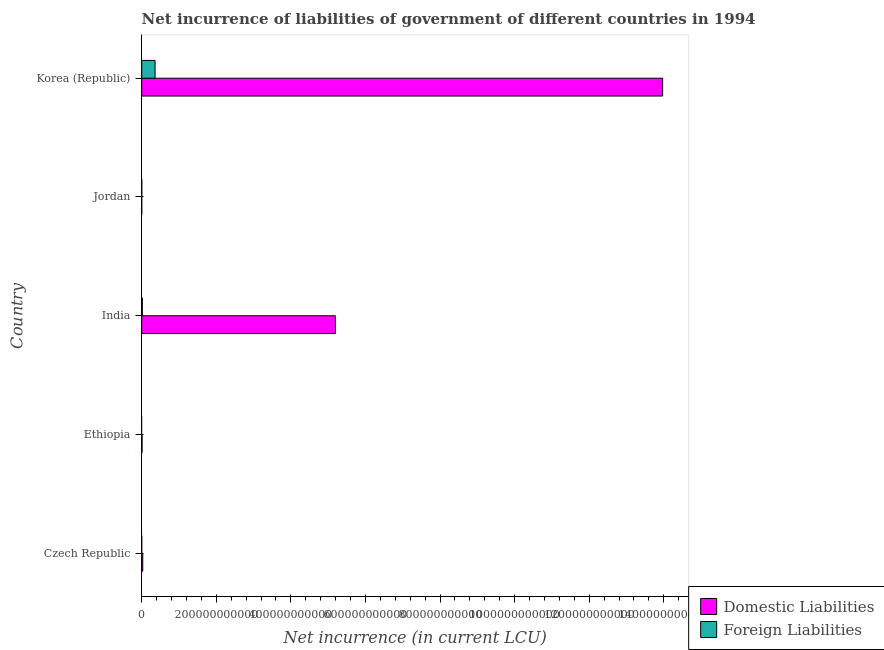Are the number of bars on each tick of the Y-axis equal?
Provide a succinct answer. No. How many bars are there on the 4th tick from the top?
Keep it short and to the point. 1. How many bars are there on the 1st tick from the bottom?
Your answer should be compact. 1. What is the label of the 5th group of bars from the top?
Ensure brevity in your answer.  Czech Republic. In how many cases, is the number of bars for a given country not equal to the number of legend labels?
Ensure brevity in your answer.  3. What is the net incurrence of domestic liabilities in Czech Republic?
Your answer should be compact. 2.80e+09. Across all countries, what is the maximum net incurrence of foreign liabilities?
Your answer should be very brief. 3.58e+1. In which country was the net incurrence of domestic liabilities maximum?
Offer a very short reply. Korea (Republic). What is the total net incurrence of foreign liabilities in the graph?
Provide a short and direct response. 3.75e+1. What is the difference between the net incurrence of foreign liabilities in India and that in Jordan?
Give a very brief answer. 1.66e+09. What is the difference between the net incurrence of domestic liabilities in Korea (Republic) and the net incurrence of foreign liabilities in Jordan?
Provide a succinct answer. 1.40e+12. What is the average net incurrence of foreign liabilities per country?
Offer a terse response. 7.50e+09. What is the difference between the net incurrence of foreign liabilities and net incurrence of domestic liabilities in India?
Ensure brevity in your answer.  -5.18e+11. What is the ratio of the net incurrence of domestic liabilities in Czech Republic to that in Ethiopia?
Offer a very short reply. 3.03. What is the difference between the highest and the second highest net incurrence of domestic liabilities?
Give a very brief answer. 8.78e+11. What is the difference between the highest and the lowest net incurrence of foreign liabilities?
Your response must be concise. 3.58e+1. What is the difference between two consecutive major ticks on the X-axis?
Offer a terse response. 2.00e+11. How many legend labels are there?
Your response must be concise. 2. What is the title of the graph?
Provide a short and direct response. Net incurrence of liabilities of government of different countries in 1994. Does "Broad money growth" appear as one of the legend labels in the graph?
Your answer should be compact. No. What is the label or title of the X-axis?
Offer a terse response. Net incurrence (in current LCU). What is the label or title of the Y-axis?
Offer a very short reply. Country. What is the Net incurrence (in current LCU) of Domestic Liabilities in Czech Republic?
Provide a succinct answer. 2.80e+09. What is the Net incurrence (in current LCU) in Foreign Liabilities in Czech Republic?
Offer a very short reply. 0. What is the Net incurrence (in current LCU) in Domestic Liabilities in Ethiopia?
Make the answer very short. 9.25e+08. What is the Net incurrence (in current LCU) of Foreign Liabilities in Ethiopia?
Your response must be concise. 0. What is the Net incurrence (in current LCU) of Domestic Liabilities in India?
Make the answer very short. 5.19e+11. What is the Net incurrence (in current LCU) in Foreign Liabilities in India?
Provide a short and direct response. 1.69e+09. What is the Net incurrence (in current LCU) of Foreign Liabilities in Jordan?
Keep it short and to the point. 3.18e+07. What is the Net incurrence (in current LCU) of Domestic Liabilities in Korea (Republic)?
Offer a very short reply. 1.40e+12. What is the Net incurrence (in current LCU) of Foreign Liabilities in Korea (Republic)?
Keep it short and to the point. 3.58e+1. Across all countries, what is the maximum Net incurrence (in current LCU) of Domestic Liabilities?
Your answer should be compact. 1.40e+12. Across all countries, what is the maximum Net incurrence (in current LCU) of Foreign Liabilities?
Keep it short and to the point. 3.58e+1. What is the total Net incurrence (in current LCU) in Domestic Liabilities in the graph?
Your answer should be very brief. 1.92e+12. What is the total Net incurrence (in current LCU) in Foreign Liabilities in the graph?
Provide a short and direct response. 3.75e+1. What is the difference between the Net incurrence (in current LCU) of Domestic Liabilities in Czech Republic and that in Ethiopia?
Offer a very short reply. 1.88e+09. What is the difference between the Net incurrence (in current LCU) in Domestic Liabilities in Czech Republic and that in India?
Offer a terse response. -5.17e+11. What is the difference between the Net incurrence (in current LCU) of Domestic Liabilities in Czech Republic and that in Korea (Republic)?
Ensure brevity in your answer.  -1.39e+12. What is the difference between the Net incurrence (in current LCU) in Domestic Liabilities in Ethiopia and that in India?
Provide a succinct answer. -5.18e+11. What is the difference between the Net incurrence (in current LCU) of Domestic Liabilities in Ethiopia and that in Korea (Republic)?
Your answer should be compact. -1.40e+12. What is the difference between the Net incurrence (in current LCU) of Foreign Liabilities in India and that in Jordan?
Keep it short and to the point. 1.66e+09. What is the difference between the Net incurrence (in current LCU) in Domestic Liabilities in India and that in Korea (Republic)?
Your response must be concise. -8.78e+11. What is the difference between the Net incurrence (in current LCU) of Foreign Liabilities in India and that in Korea (Republic)?
Keep it short and to the point. -3.41e+1. What is the difference between the Net incurrence (in current LCU) of Foreign Liabilities in Jordan and that in Korea (Republic)?
Ensure brevity in your answer.  -3.58e+1. What is the difference between the Net incurrence (in current LCU) of Domestic Liabilities in Czech Republic and the Net incurrence (in current LCU) of Foreign Liabilities in India?
Offer a terse response. 1.11e+09. What is the difference between the Net incurrence (in current LCU) of Domestic Liabilities in Czech Republic and the Net incurrence (in current LCU) of Foreign Liabilities in Jordan?
Give a very brief answer. 2.77e+09. What is the difference between the Net incurrence (in current LCU) in Domestic Liabilities in Czech Republic and the Net incurrence (in current LCU) in Foreign Liabilities in Korea (Republic)?
Your answer should be compact. -3.30e+1. What is the difference between the Net incurrence (in current LCU) of Domestic Liabilities in Ethiopia and the Net incurrence (in current LCU) of Foreign Liabilities in India?
Offer a very short reply. -7.65e+08. What is the difference between the Net incurrence (in current LCU) of Domestic Liabilities in Ethiopia and the Net incurrence (in current LCU) of Foreign Liabilities in Jordan?
Offer a very short reply. 8.93e+08. What is the difference between the Net incurrence (in current LCU) of Domestic Liabilities in Ethiopia and the Net incurrence (in current LCU) of Foreign Liabilities in Korea (Republic)?
Ensure brevity in your answer.  -3.49e+1. What is the difference between the Net incurrence (in current LCU) in Domestic Liabilities in India and the Net incurrence (in current LCU) in Foreign Liabilities in Jordan?
Provide a short and direct response. 5.19e+11. What is the difference between the Net incurrence (in current LCU) of Domestic Liabilities in India and the Net incurrence (in current LCU) of Foreign Liabilities in Korea (Republic)?
Your answer should be compact. 4.84e+11. What is the average Net incurrence (in current LCU) in Domestic Liabilities per country?
Ensure brevity in your answer.  3.84e+11. What is the average Net incurrence (in current LCU) in Foreign Liabilities per country?
Your response must be concise. 7.50e+09. What is the difference between the Net incurrence (in current LCU) in Domestic Liabilities and Net incurrence (in current LCU) in Foreign Liabilities in India?
Provide a succinct answer. 5.18e+11. What is the difference between the Net incurrence (in current LCU) in Domestic Liabilities and Net incurrence (in current LCU) in Foreign Liabilities in Korea (Republic)?
Provide a short and direct response. 1.36e+12. What is the ratio of the Net incurrence (in current LCU) in Domestic Liabilities in Czech Republic to that in Ethiopia?
Ensure brevity in your answer.  3.03. What is the ratio of the Net incurrence (in current LCU) of Domestic Liabilities in Czech Republic to that in India?
Make the answer very short. 0.01. What is the ratio of the Net incurrence (in current LCU) in Domestic Liabilities in Czech Republic to that in Korea (Republic)?
Offer a terse response. 0. What is the ratio of the Net incurrence (in current LCU) of Domestic Liabilities in Ethiopia to that in India?
Your response must be concise. 0. What is the ratio of the Net incurrence (in current LCU) of Domestic Liabilities in Ethiopia to that in Korea (Republic)?
Your answer should be very brief. 0. What is the ratio of the Net incurrence (in current LCU) of Foreign Liabilities in India to that in Jordan?
Ensure brevity in your answer.  53.17. What is the ratio of the Net incurrence (in current LCU) in Domestic Liabilities in India to that in Korea (Republic)?
Make the answer very short. 0.37. What is the ratio of the Net incurrence (in current LCU) in Foreign Liabilities in India to that in Korea (Republic)?
Offer a very short reply. 0.05. What is the ratio of the Net incurrence (in current LCU) of Foreign Liabilities in Jordan to that in Korea (Republic)?
Offer a terse response. 0. What is the difference between the highest and the second highest Net incurrence (in current LCU) of Domestic Liabilities?
Give a very brief answer. 8.78e+11. What is the difference between the highest and the second highest Net incurrence (in current LCU) in Foreign Liabilities?
Your answer should be compact. 3.41e+1. What is the difference between the highest and the lowest Net incurrence (in current LCU) in Domestic Liabilities?
Ensure brevity in your answer.  1.40e+12. What is the difference between the highest and the lowest Net incurrence (in current LCU) in Foreign Liabilities?
Keep it short and to the point. 3.58e+1. 